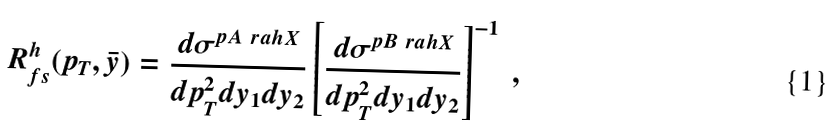Convert formula to latex. <formula><loc_0><loc_0><loc_500><loc_500>R _ { f s } ^ { h } ( p _ { T } , \bar { y } ) = \frac { d \sigma ^ { p A \ r a h X } } { d p _ { T } ^ { 2 } d y _ { 1 } d y _ { 2 } } \left [ \frac { d \sigma ^ { p B \ r a h X } } { d p _ { T } ^ { 2 } d y _ { 1 } d y _ { 2 } } \right ] ^ { - 1 } \ ,</formula> 